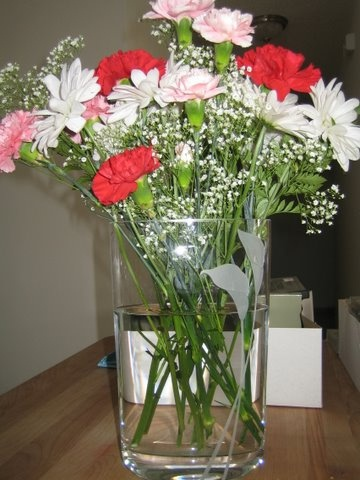Describe the objects in this image and their specific colors. I can see vase in gray, darkgreen, and darkgray tones and dining table in gray, maroon, and black tones in this image. 